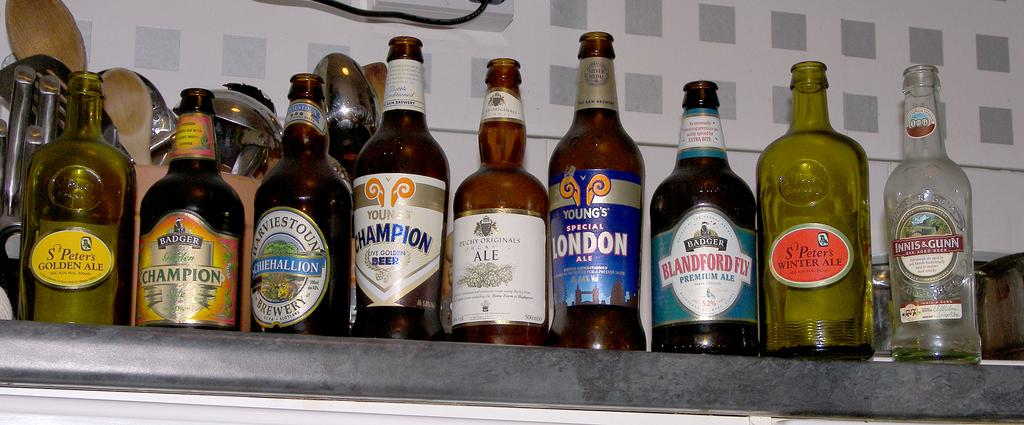Provide a one-sentence caption for the provided image. a beer bottle with the word Blandford on the front. 